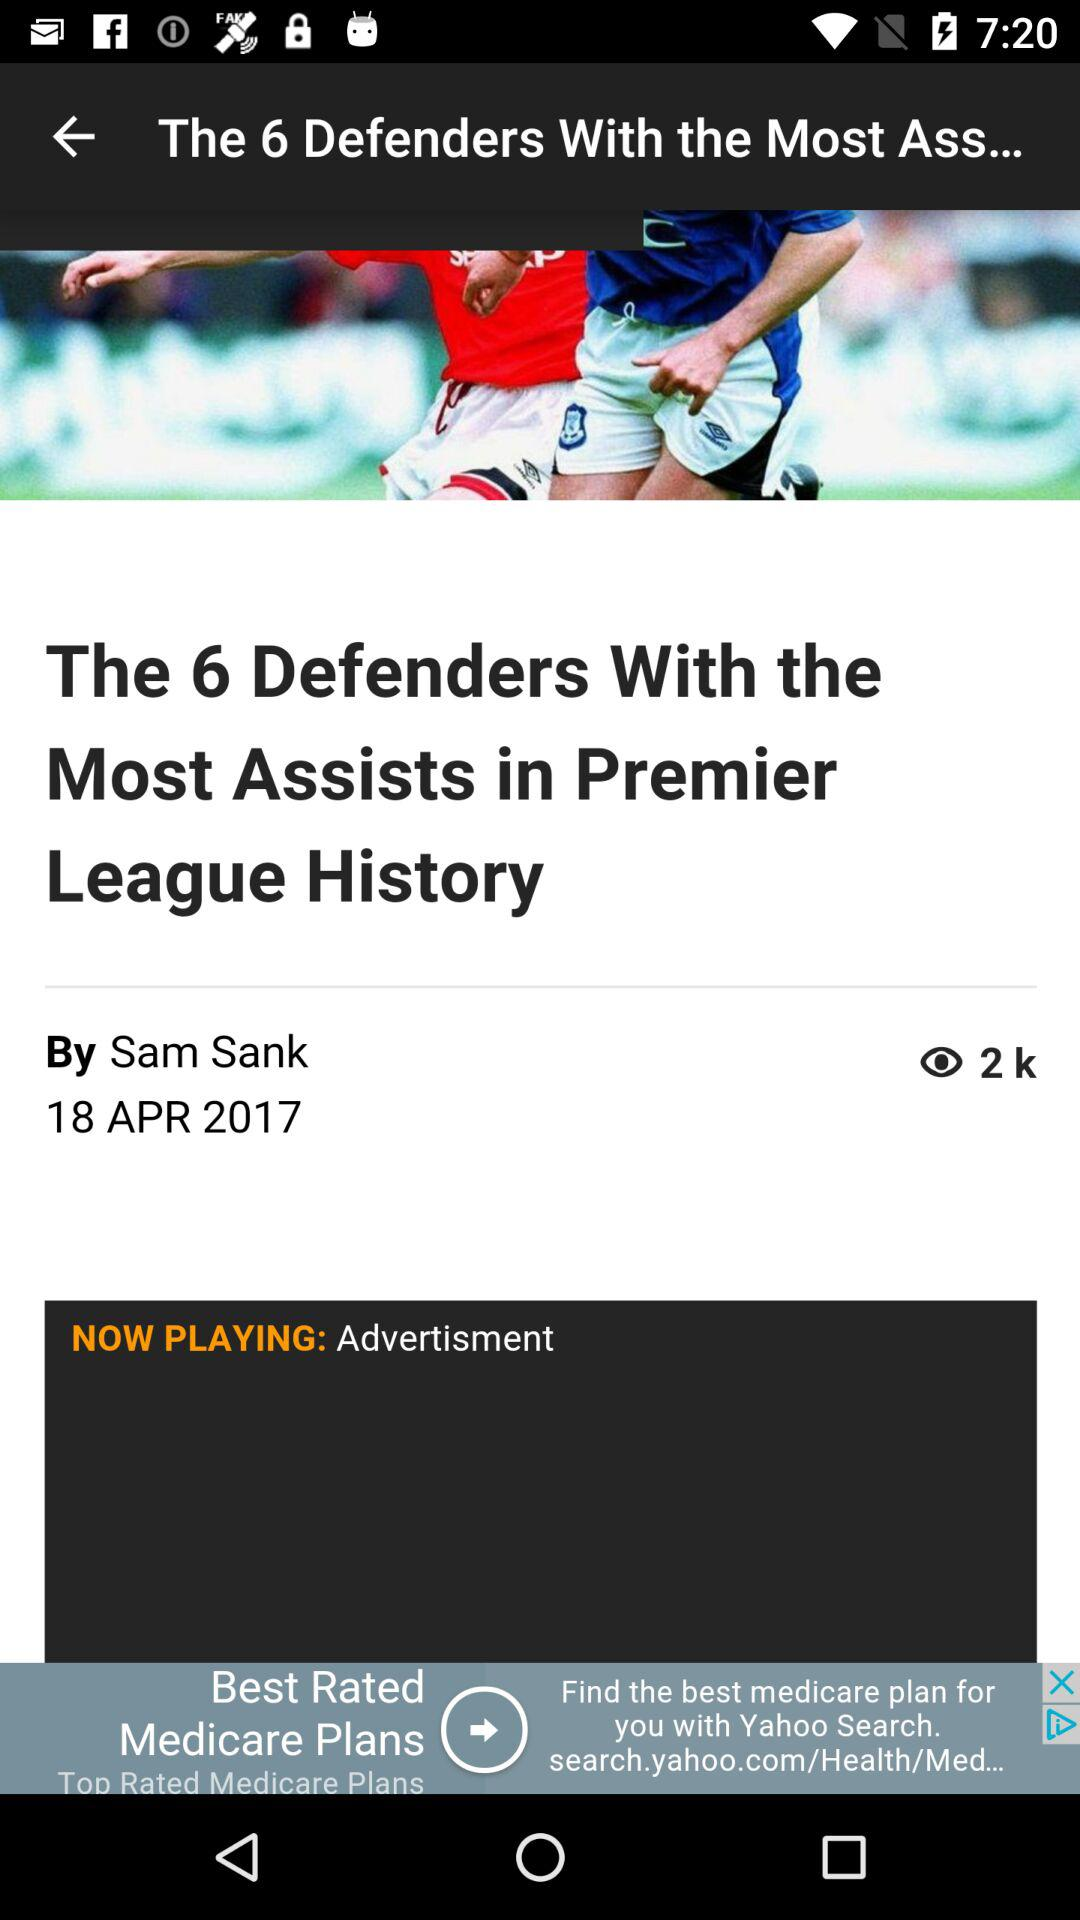When was the article published? The article was published on April 18, 2017. 